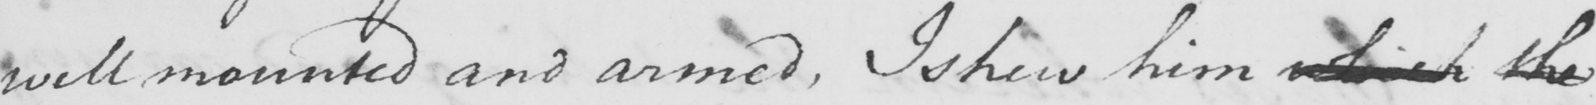Transcribe the text shown in this historical manuscript line. well mounted and armed , I shew him which the 